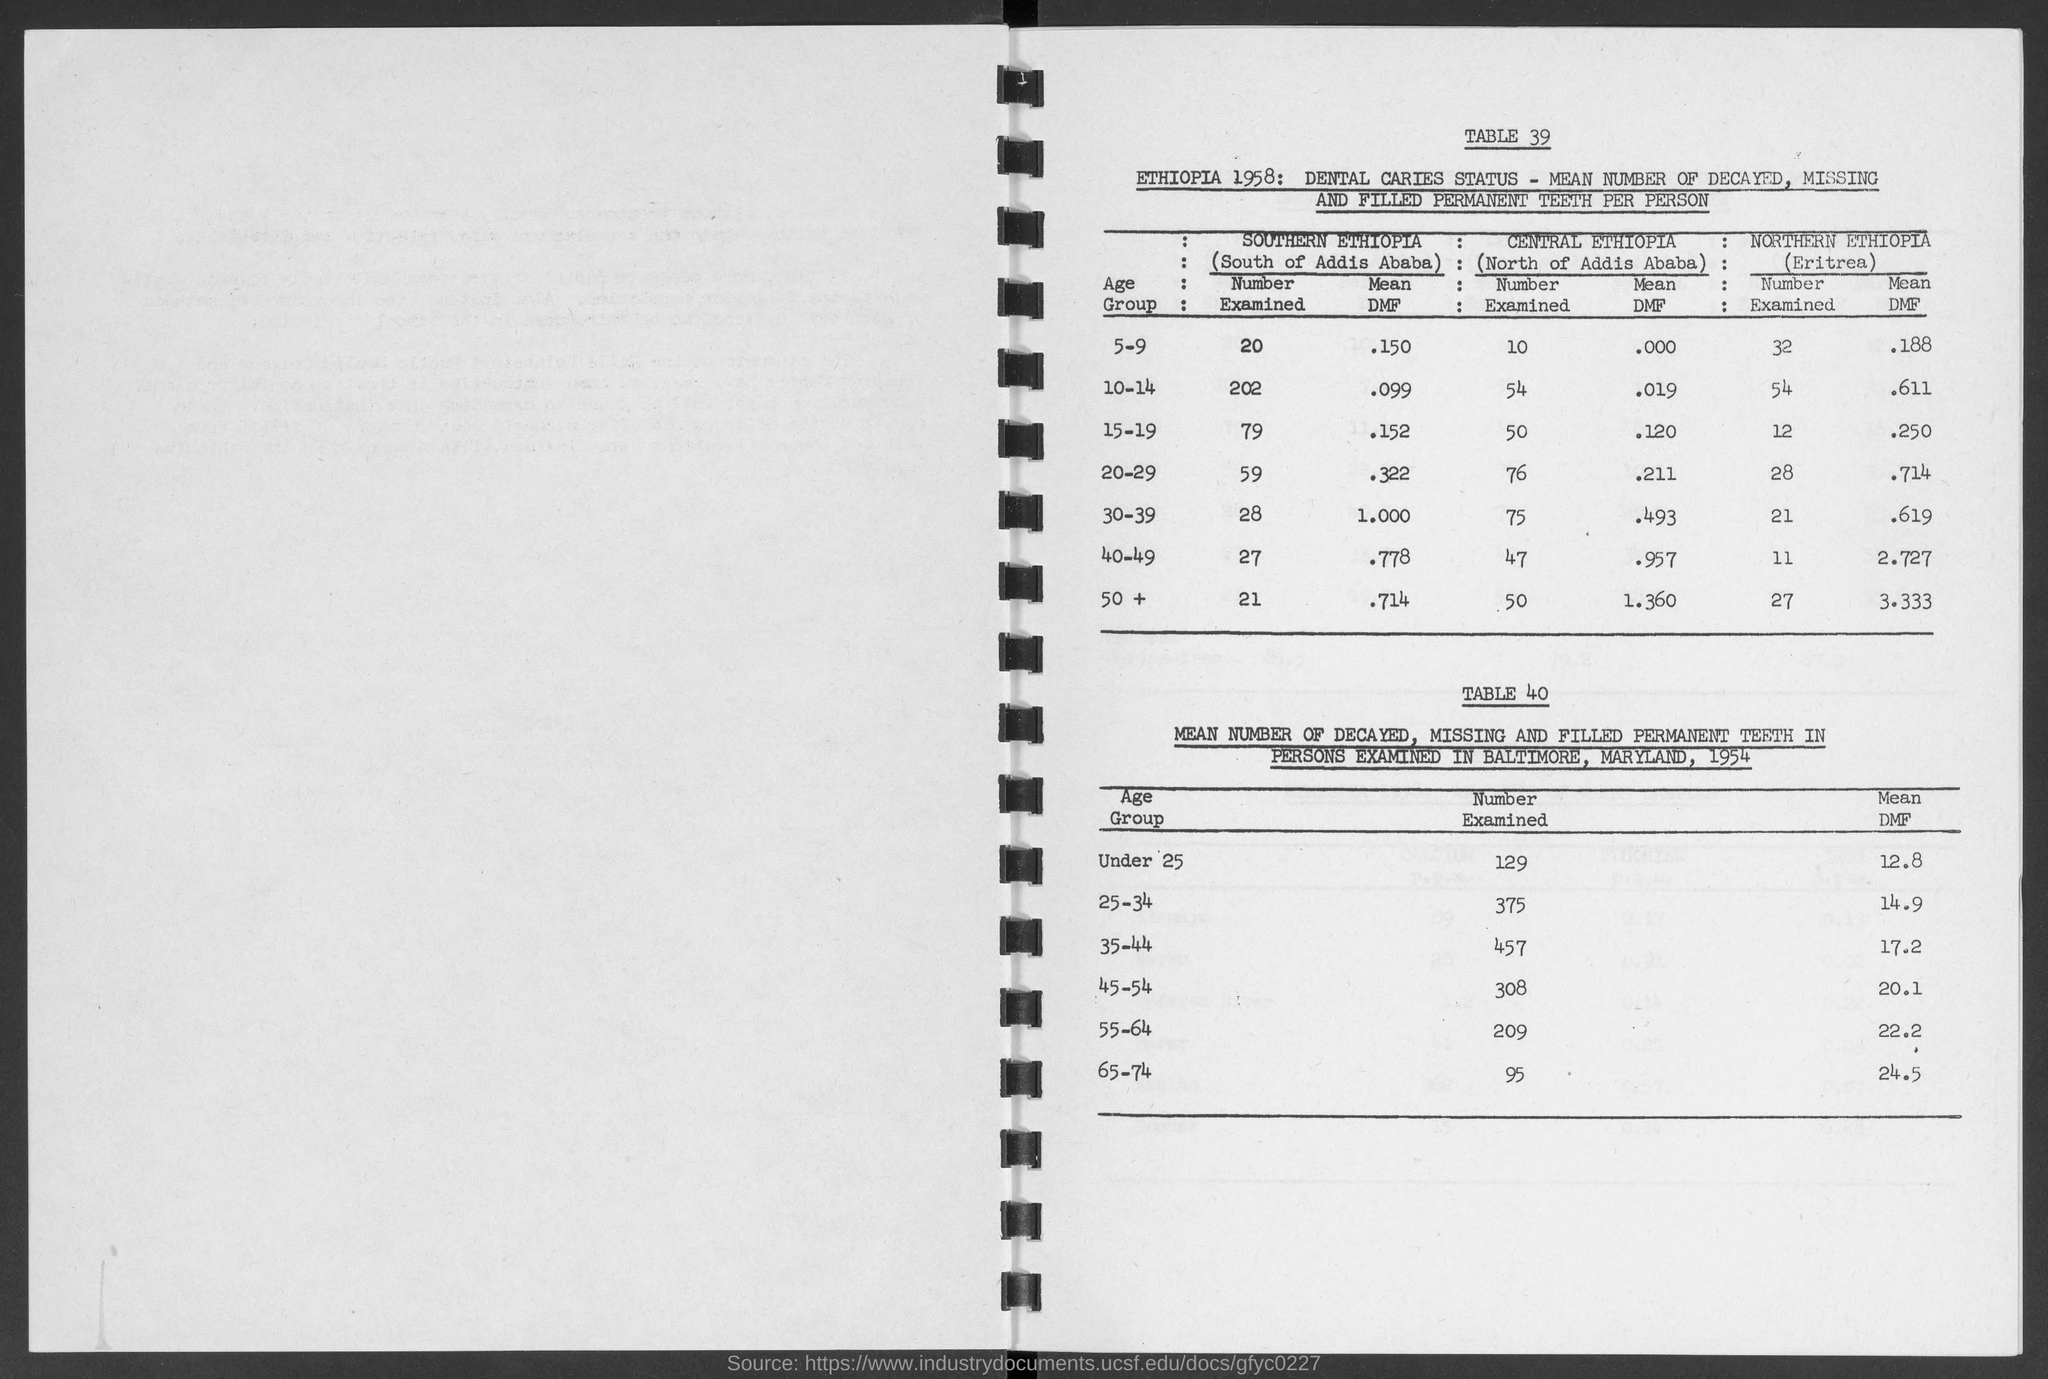What is the number examined in southern ethiopia in age group of 5-9 ?
Make the answer very short. 20. What is the number examined in southern ethiopia in age group of 10-14 ?
Your response must be concise. 202. What is the number examined in southern ethiopia in age group of 15-19?
Offer a very short reply. 79. What is the number examined in southern ethiopia in age group of 20-29 ?
Offer a terse response. 59. What is the number examined in southern ethiopia in age group of 30-39 ?
Offer a very short reply. 28. What is the number examined in southern ethiopia in age group of 40-49 ?
Your answer should be compact. 27. What is the number examined in southern ethiopia in age group of +50 ?
Your response must be concise. 21. What is the mean dmf in southern ethiopia in age group of 5-9 ?
Keep it short and to the point. .150. What is the mean dmf in southern ethiopia in age group of 15-19?
Your response must be concise. .152. 